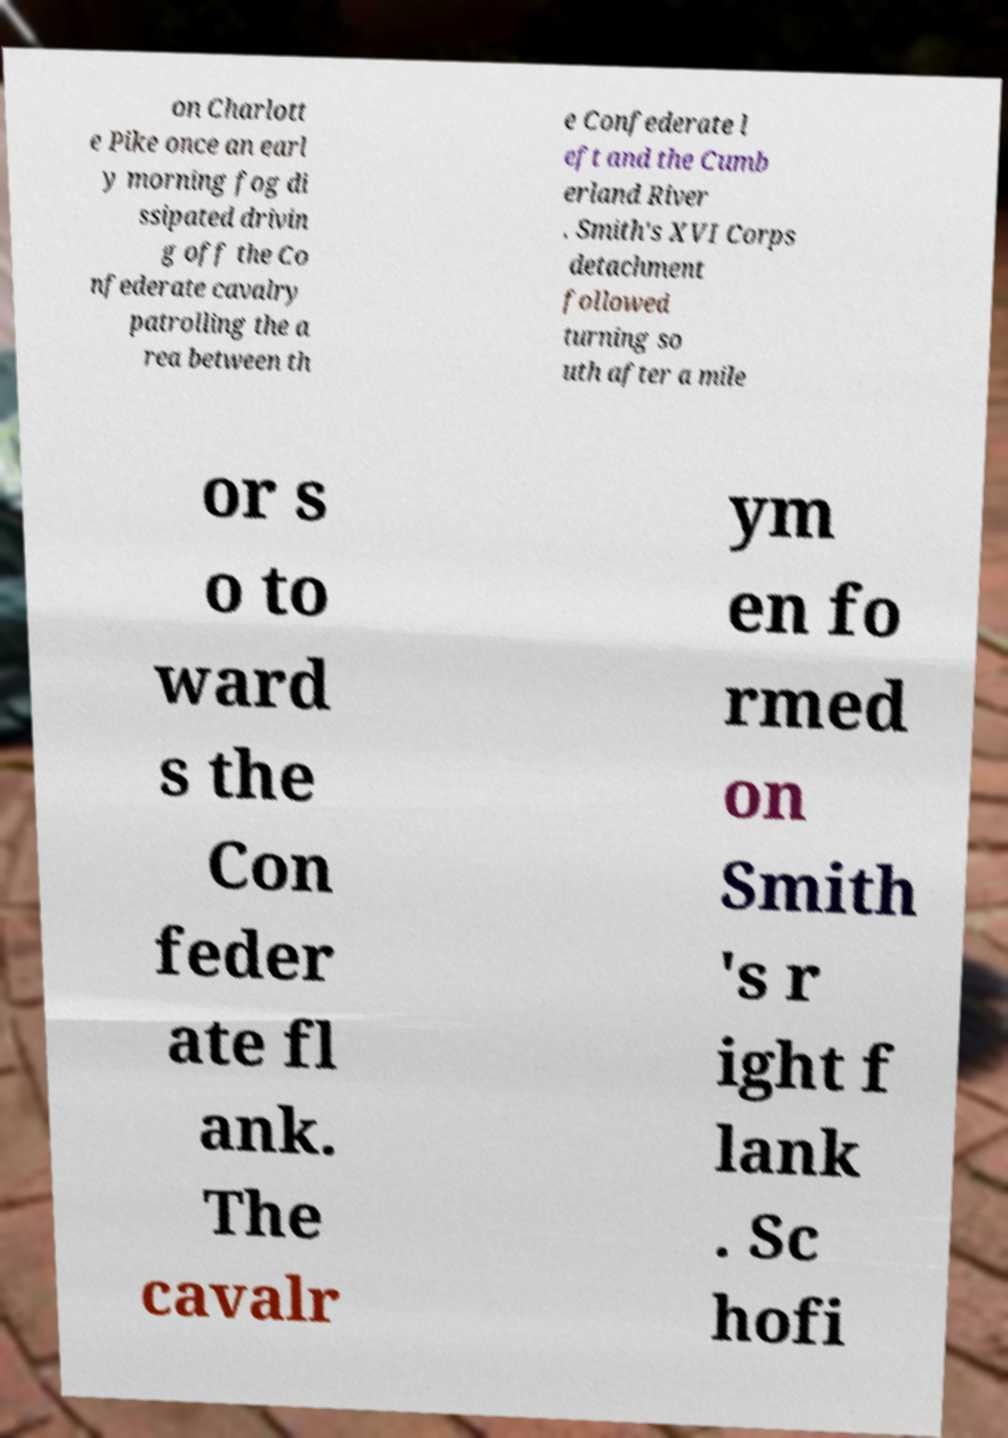Could you assist in decoding the text presented in this image and type it out clearly? on Charlott e Pike once an earl y morning fog di ssipated drivin g off the Co nfederate cavalry patrolling the a rea between th e Confederate l eft and the Cumb erland River . Smith's XVI Corps detachment followed turning so uth after a mile or s o to ward s the Con feder ate fl ank. The cavalr ym en fo rmed on Smith 's r ight f lank . Sc hofi 